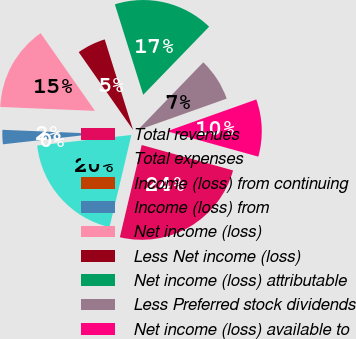Convert chart. <chart><loc_0><loc_0><loc_500><loc_500><pie_chart><fcel>Total revenues<fcel>Total expenses<fcel>Income (loss) from continuing<fcel>Income (loss) from<fcel>Net income (loss)<fcel>Less Net income (loss)<fcel>Net income (loss) attributable<fcel>Less Preferred stock dividends<fcel>Net income (loss) available to<nl><fcel>24.39%<fcel>19.51%<fcel>0.0%<fcel>2.44%<fcel>14.63%<fcel>4.88%<fcel>17.07%<fcel>7.32%<fcel>9.76%<nl></chart> 